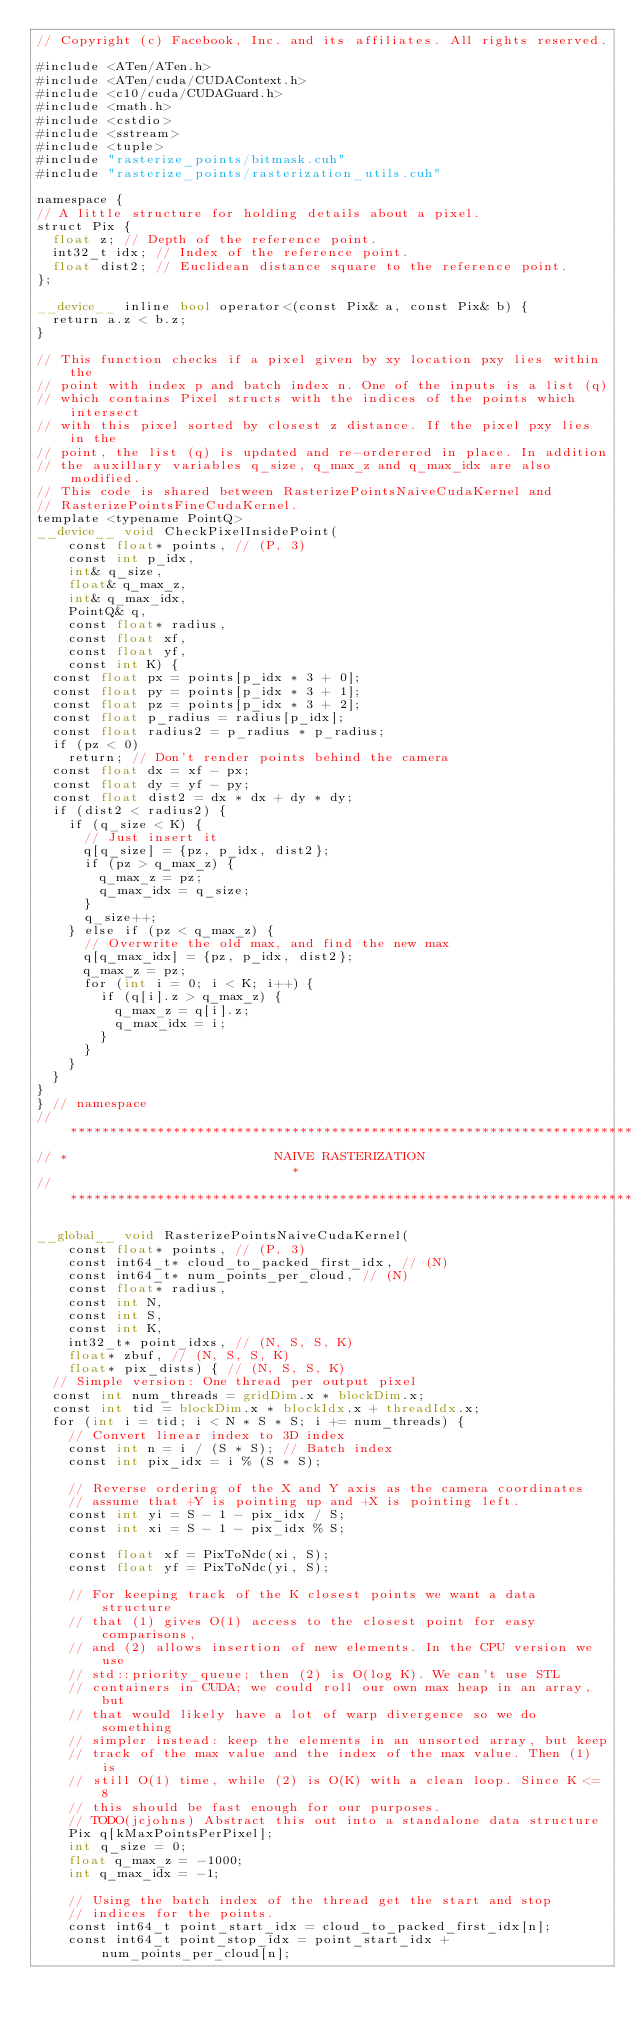Convert code to text. <code><loc_0><loc_0><loc_500><loc_500><_Cuda_>// Copyright (c) Facebook, Inc. and its affiliates. All rights reserved.

#include <ATen/ATen.h>
#include <ATen/cuda/CUDAContext.h>
#include <c10/cuda/CUDAGuard.h>
#include <math.h>
#include <cstdio>
#include <sstream>
#include <tuple>
#include "rasterize_points/bitmask.cuh"
#include "rasterize_points/rasterization_utils.cuh"

namespace {
// A little structure for holding details about a pixel.
struct Pix {
  float z; // Depth of the reference point.
  int32_t idx; // Index of the reference point.
  float dist2; // Euclidean distance square to the reference point.
};

__device__ inline bool operator<(const Pix& a, const Pix& b) {
  return a.z < b.z;
}

// This function checks if a pixel given by xy location pxy lies within the
// point with index p and batch index n. One of the inputs is a list (q)
// which contains Pixel structs with the indices of the points which intersect
// with this pixel sorted by closest z distance. If the pixel pxy lies in the
// point, the list (q) is updated and re-orderered in place. In addition
// the auxillary variables q_size, q_max_z and q_max_idx are also modified.
// This code is shared between RasterizePointsNaiveCudaKernel and
// RasterizePointsFineCudaKernel.
template <typename PointQ>
__device__ void CheckPixelInsidePoint(
    const float* points, // (P, 3)
    const int p_idx,
    int& q_size,
    float& q_max_z,
    int& q_max_idx,
    PointQ& q,
    const float* radius,
    const float xf,
    const float yf,
    const int K) {
  const float px = points[p_idx * 3 + 0];
  const float py = points[p_idx * 3 + 1];
  const float pz = points[p_idx * 3 + 2];
  const float p_radius = radius[p_idx];
  const float radius2 = p_radius * p_radius;
  if (pz < 0)
    return; // Don't render points behind the camera
  const float dx = xf - px;
  const float dy = yf - py;
  const float dist2 = dx * dx + dy * dy;
  if (dist2 < radius2) {
    if (q_size < K) {
      // Just insert it
      q[q_size] = {pz, p_idx, dist2};
      if (pz > q_max_z) {
        q_max_z = pz;
        q_max_idx = q_size;
      }
      q_size++;
    } else if (pz < q_max_z) {
      // Overwrite the old max, and find the new max
      q[q_max_idx] = {pz, p_idx, dist2};
      q_max_z = pz;
      for (int i = 0; i < K; i++) {
        if (q[i].z > q_max_z) {
          q_max_z = q[i].z;
          q_max_idx = i;
        }
      }
    }
  }
}
} // namespace
// ****************************************************************************
// *                          NAIVE RASTERIZATION                             *
// ****************************************************************************

__global__ void RasterizePointsNaiveCudaKernel(
    const float* points, // (P, 3)
    const int64_t* cloud_to_packed_first_idx, // (N)
    const int64_t* num_points_per_cloud, // (N)
    const float* radius,
    const int N,
    const int S,
    const int K,
    int32_t* point_idxs, // (N, S, S, K)
    float* zbuf, // (N, S, S, K)
    float* pix_dists) { // (N, S, S, K)
  // Simple version: One thread per output pixel
  const int num_threads = gridDim.x * blockDim.x;
  const int tid = blockDim.x * blockIdx.x + threadIdx.x;
  for (int i = tid; i < N * S * S; i += num_threads) {
    // Convert linear index to 3D index
    const int n = i / (S * S); // Batch index
    const int pix_idx = i % (S * S);

    // Reverse ordering of the X and Y axis as the camera coordinates
    // assume that +Y is pointing up and +X is pointing left.
    const int yi = S - 1 - pix_idx / S;
    const int xi = S - 1 - pix_idx % S;

    const float xf = PixToNdc(xi, S);
    const float yf = PixToNdc(yi, S);

    // For keeping track of the K closest points we want a data structure
    // that (1) gives O(1) access to the closest point for easy comparisons,
    // and (2) allows insertion of new elements. In the CPU version we use
    // std::priority_queue; then (2) is O(log K). We can't use STL
    // containers in CUDA; we could roll our own max heap in an array, but
    // that would likely have a lot of warp divergence so we do something
    // simpler instead: keep the elements in an unsorted array, but keep
    // track of the max value and the index of the max value. Then (1) is
    // still O(1) time, while (2) is O(K) with a clean loop. Since K <= 8
    // this should be fast enough for our purposes.
    // TODO(jcjohns) Abstract this out into a standalone data structure
    Pix q[kMaxPointsPerPixel];
    int q_size = 0;
    float q_max_z = -1000;
    int q_max_idx = -1;

    // Using the batch index of the thread get the start and stop
    // indices for the points.
    const int64_t point_start_idx = cloud_to_packed_first_idx[n];
    const int64_t point_stop_idx = point_start_idx + num_points_per_cloud[n];
</code> 